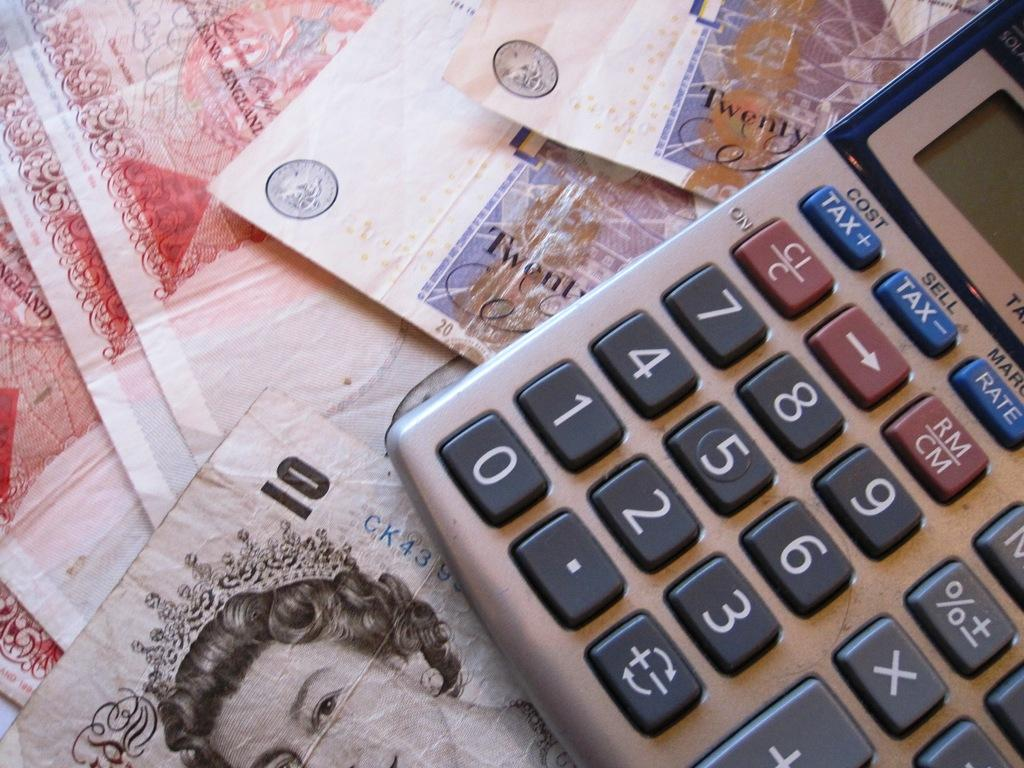<image>
Create a compact narrative representing the image presented. A calculator, with tax and rate buttons, is resting on top of some money. 